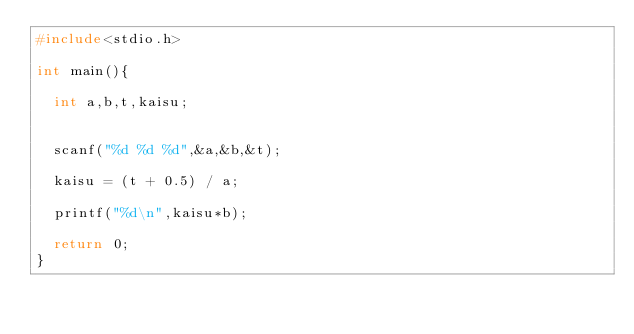<code> <loc_0><loc_0><loc_500><loc_500><_C_>#include<stdio.h>

int main(){

  int a,b,t,kaisu;


  scanf("%d %d %d",&a,&b,&t);

  kaisu = (t + 0.5) / a;

  printf("%d\n",kaisu*b);

  return 0;
}
</code> 